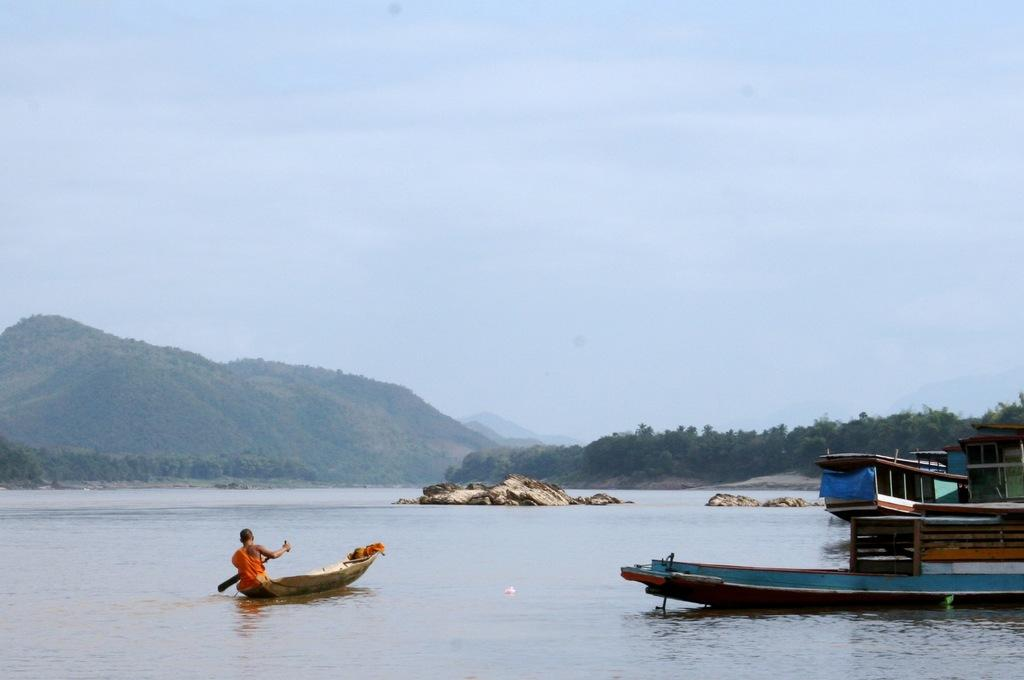What can be seen in the lake in the image? There are boats in the lake in the image. What is the monk doing in the image? A monk is rowing a small boat in the image. What can be seen in the background of the image? There are hills covered with trees in the background of the image. What is visible above the hills in the image? The sky is visible above the hills in the image. What type of stocking is the monk wearing while rowing the boat? There is no mention of stockings in the image, and the monk's attire is not described in detail. What treatment is being administered to the lake in the image? There is no indication of any treatment being administered to the lake in the image. 